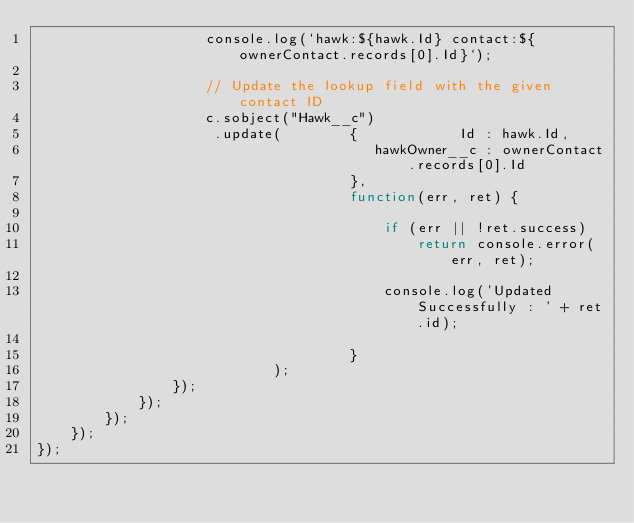Convert code to text. <code><loc_0><loc_0><loc_500><loc_500><_JavaScript_>                    console.log(`hawk:${hawk.Id} contact:${ownerContact.records[0].Id}`);

                    // Update the lookup field with the given contact ID
                    c.sobject("Hawk__c")
                     .update(        {            Id : hawk.Id,
                                        hawkOwner__c : ownerContact.records[0].Id
                                     },
                                     function(err, ret) {

                                         if (err || !ret.success)
                                             return console.error(err, ret);

                                         console.log('Updated Successfully : ' + ret.id);

                                     }
                            );
                });
            });
        });
    });
});
</code> 